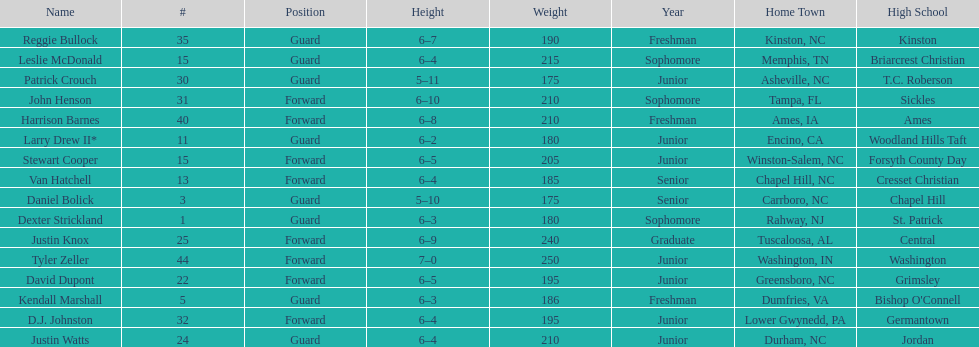How many players are not a junior? 9. 